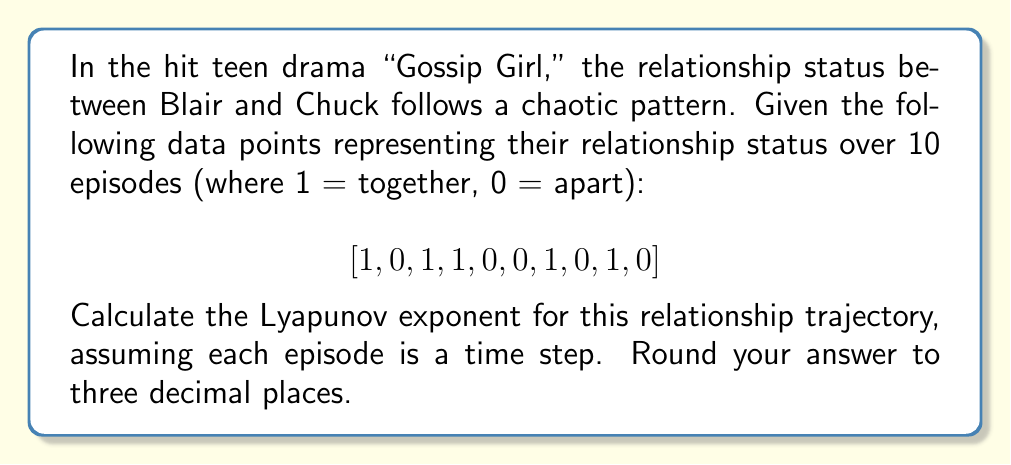Show me your answer to this math problem. To calculate the Lyapunov exponent for this teen drama plot trajectory, we'll follow these steps:

1) The Lyapunov exponent (λ) for a time series is given by:

   $$\lambda = \frac{1}{N} \sum_{i=1}^N \ln \left|\frac{df}{dx_i}\right|$$

   where N is the number of time steps, and $\frac{df}{dx_i}$ is the rate of change at each point.

2) In this case, we have a discrete series, so we'll use the difference between consecutive points as our rate of change:

   $$\frac{df}{dx_i} \approx |x_{i+1} - x_i|$$

3) Let's calculate this for each pair of consecutive points:
   
   |1-0| = 1
   |0-1| = 1
   |1-1| = 0
   |1-0| = 1
   |0-0| = 0
   |0-1| = 1
   |1-0| = 1
   |0-1| = 1
   |1-0| = 1

4) Now, we need to calculate $\ln|1|$ for each non-zero difference and sum them:
   
   $\ln(1) + \ln(1) + \ln(1) + \ln(1) + \ln(1) + \ln(1) + \ln(1) = 7 * 0 = 0$

5) For the zero differences, $\ln(0)$ is undefined, so we'll exclude these from our calculation and adjust N accordingly.

6) We have 9 transitions in total, and 7 of them are non-zero. So our adjusted N is 7.

7) Applying the formula:

   $$\lambda = \frac{1}{7} * 0 = 0$$

8) Rounding to three decimal places:

   $$\lambda \approx 0.000$$
Answer: 0.000 